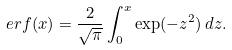<formula> <loc_0><loc_0><loc_500><loc_500>e r f ( x ) = \frac { 2 } { \sqrt { \pi } } \int _ { 0 } ^ { x } \exp ( - z ^ { 2 } ) \, d z .</formula> 